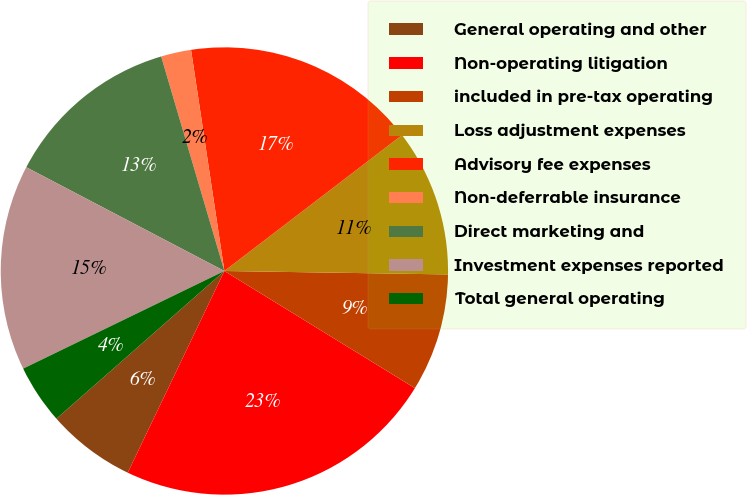Convert chart. <chart><loc_0><loc_0><loc_500><loc_500><pie_chart><fcel>General operating and other<fcel>Non-operating litigation<fcel>included in pre-tax operating<fcel>Loss adjustment expenses<fcel>Advisory fee expenses<fcel>Non-deferrable insurance<fcel>Direct marketing and<fcel>Investment expenses reported<fcel>Total general operating<nl><fcel>6.41%<fcel>23.34%<fcel>8.53%<fcel>10.64%<fcel>16.99%<fcel>2.18%<fcel>12.76%<fcel>14.87%<fcel>4.29%<nl></chart> 